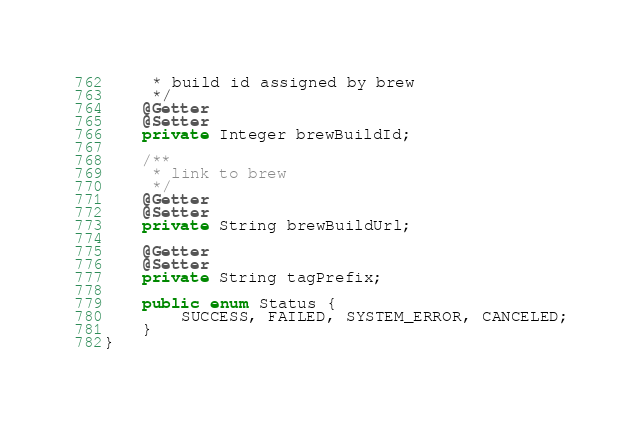<code> <loc_0><loc_0><loc_500><loc_500><_Java_>     * build id assigned by brew
     */
    @Getter
    @Setter
    private Integer brewBuildId;

    /**
     * link to brew
     */
    @Getter
    @Setter
    private String brewBuildUrl;

    @Getter
    @Setter
    private String tagPrefix;

    public enum Status {
        SUCCESS, FAILED, SYSTEM_ERROR, CANCELED;
    }
}
</code> 